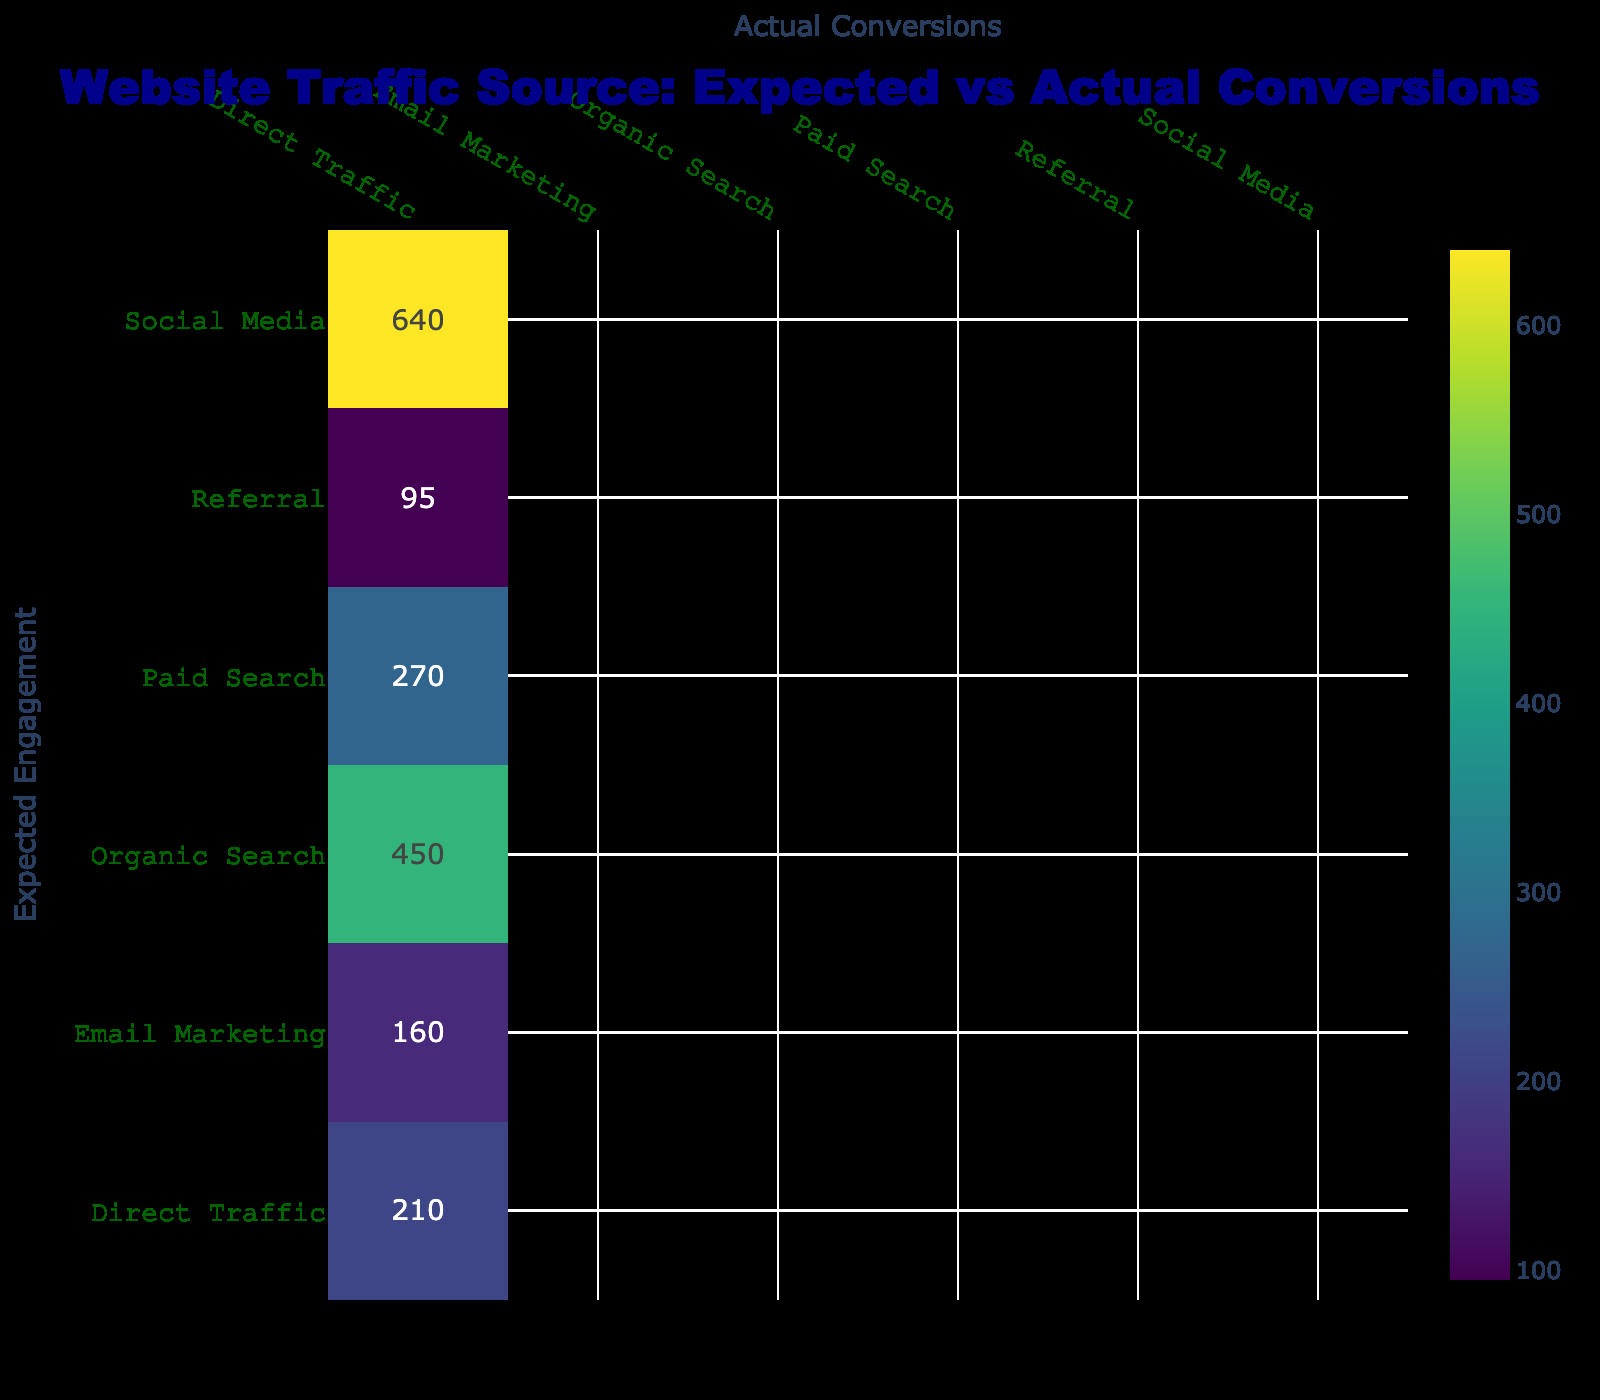What is the total number of actual conversions from Organic Search? To find the total actual conversions from Organic Search, I need to sum the values corresponding to that source: (120 + 150 + 180) = 450.
Answer: 450 What is the average number of actual conversions for Paid Search? There are 3 data points for Paid Search (100, 80, 90). To find the average, I sum these values: 100 + 80 + 90 = 270. Then, divide by 3, which gives me 270 / 3 = 90.
Answer: 90 True or False: The actual conversions from Email Marketing exceeded 100. The total actual conversions for Email Marketing are (50 + 40 + 70) = 160, which is greater than 100.
Answer: True Which traffic source had the highest total actual conversions? I can determine the highest total by calculating the sum of actual conversions for each source: Organic Search = 450, Paid Search = 270, Social Media = 630, Email Marketing = 160, Referral = 95, Direct Traffic = 210. The highest is Social Media with 630.
Answer: Social Media What is the difference between the total actual conversions from Direct Traffic and Organic Search? The total actual conversions from Direct Traffic is 210 and from Organic Search is 450. To find the difference, I subtract: 450 - 210 = 240.
Answer: 240 